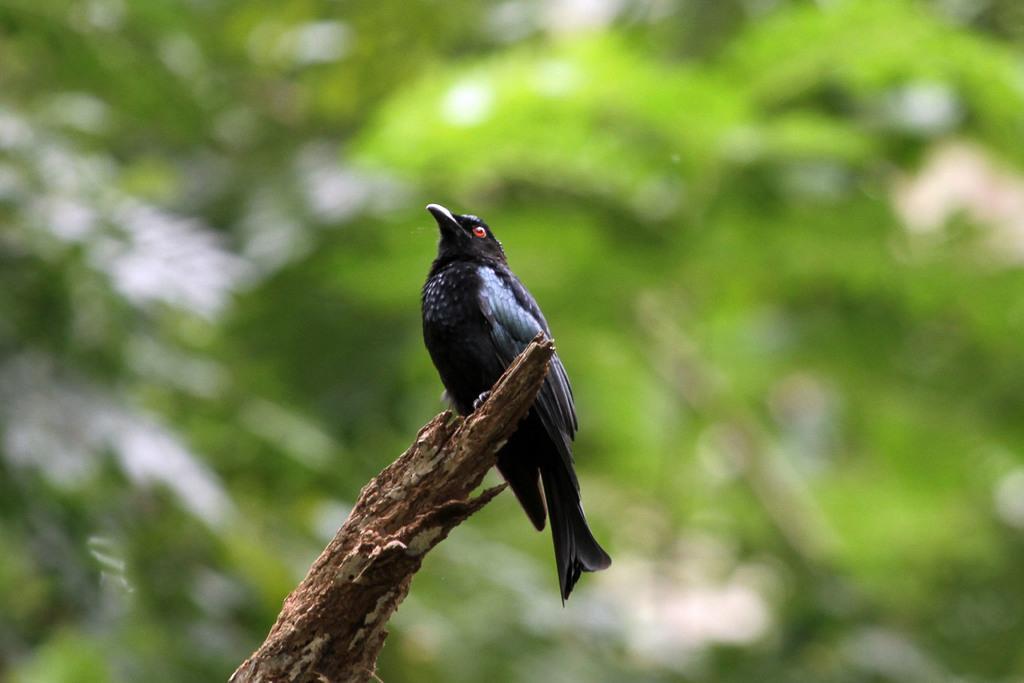Can you describe this image briefly? In this picture we can see a bird on the branch. Behind the bird, there is a blurred background. 